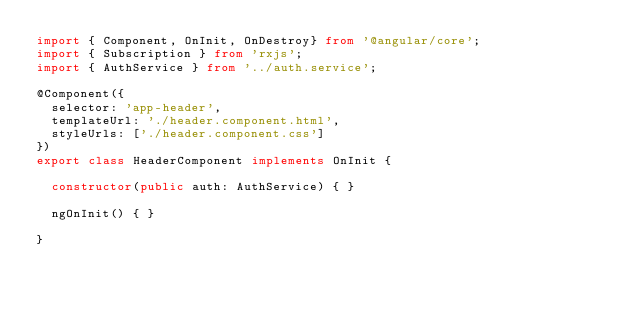Convert code to text. <code><loc_0><loc_0><loc_500><loc_500><_TypeScript_>import { Component, OnInit, OnDestroy} from '@angular/core';
import { Subscription } from 'rxjs';
import { AuthService } from '../auth.service';

@Component({
  selector: 'app-header',
  templateUrl: './header.component.html',
  styleUrls: ['./header.component.css']
})
export class HeaderComponent implements OnInit {

  constructor(public auth: AuthService) { }

  ngOnInit() { }

}
</code> 